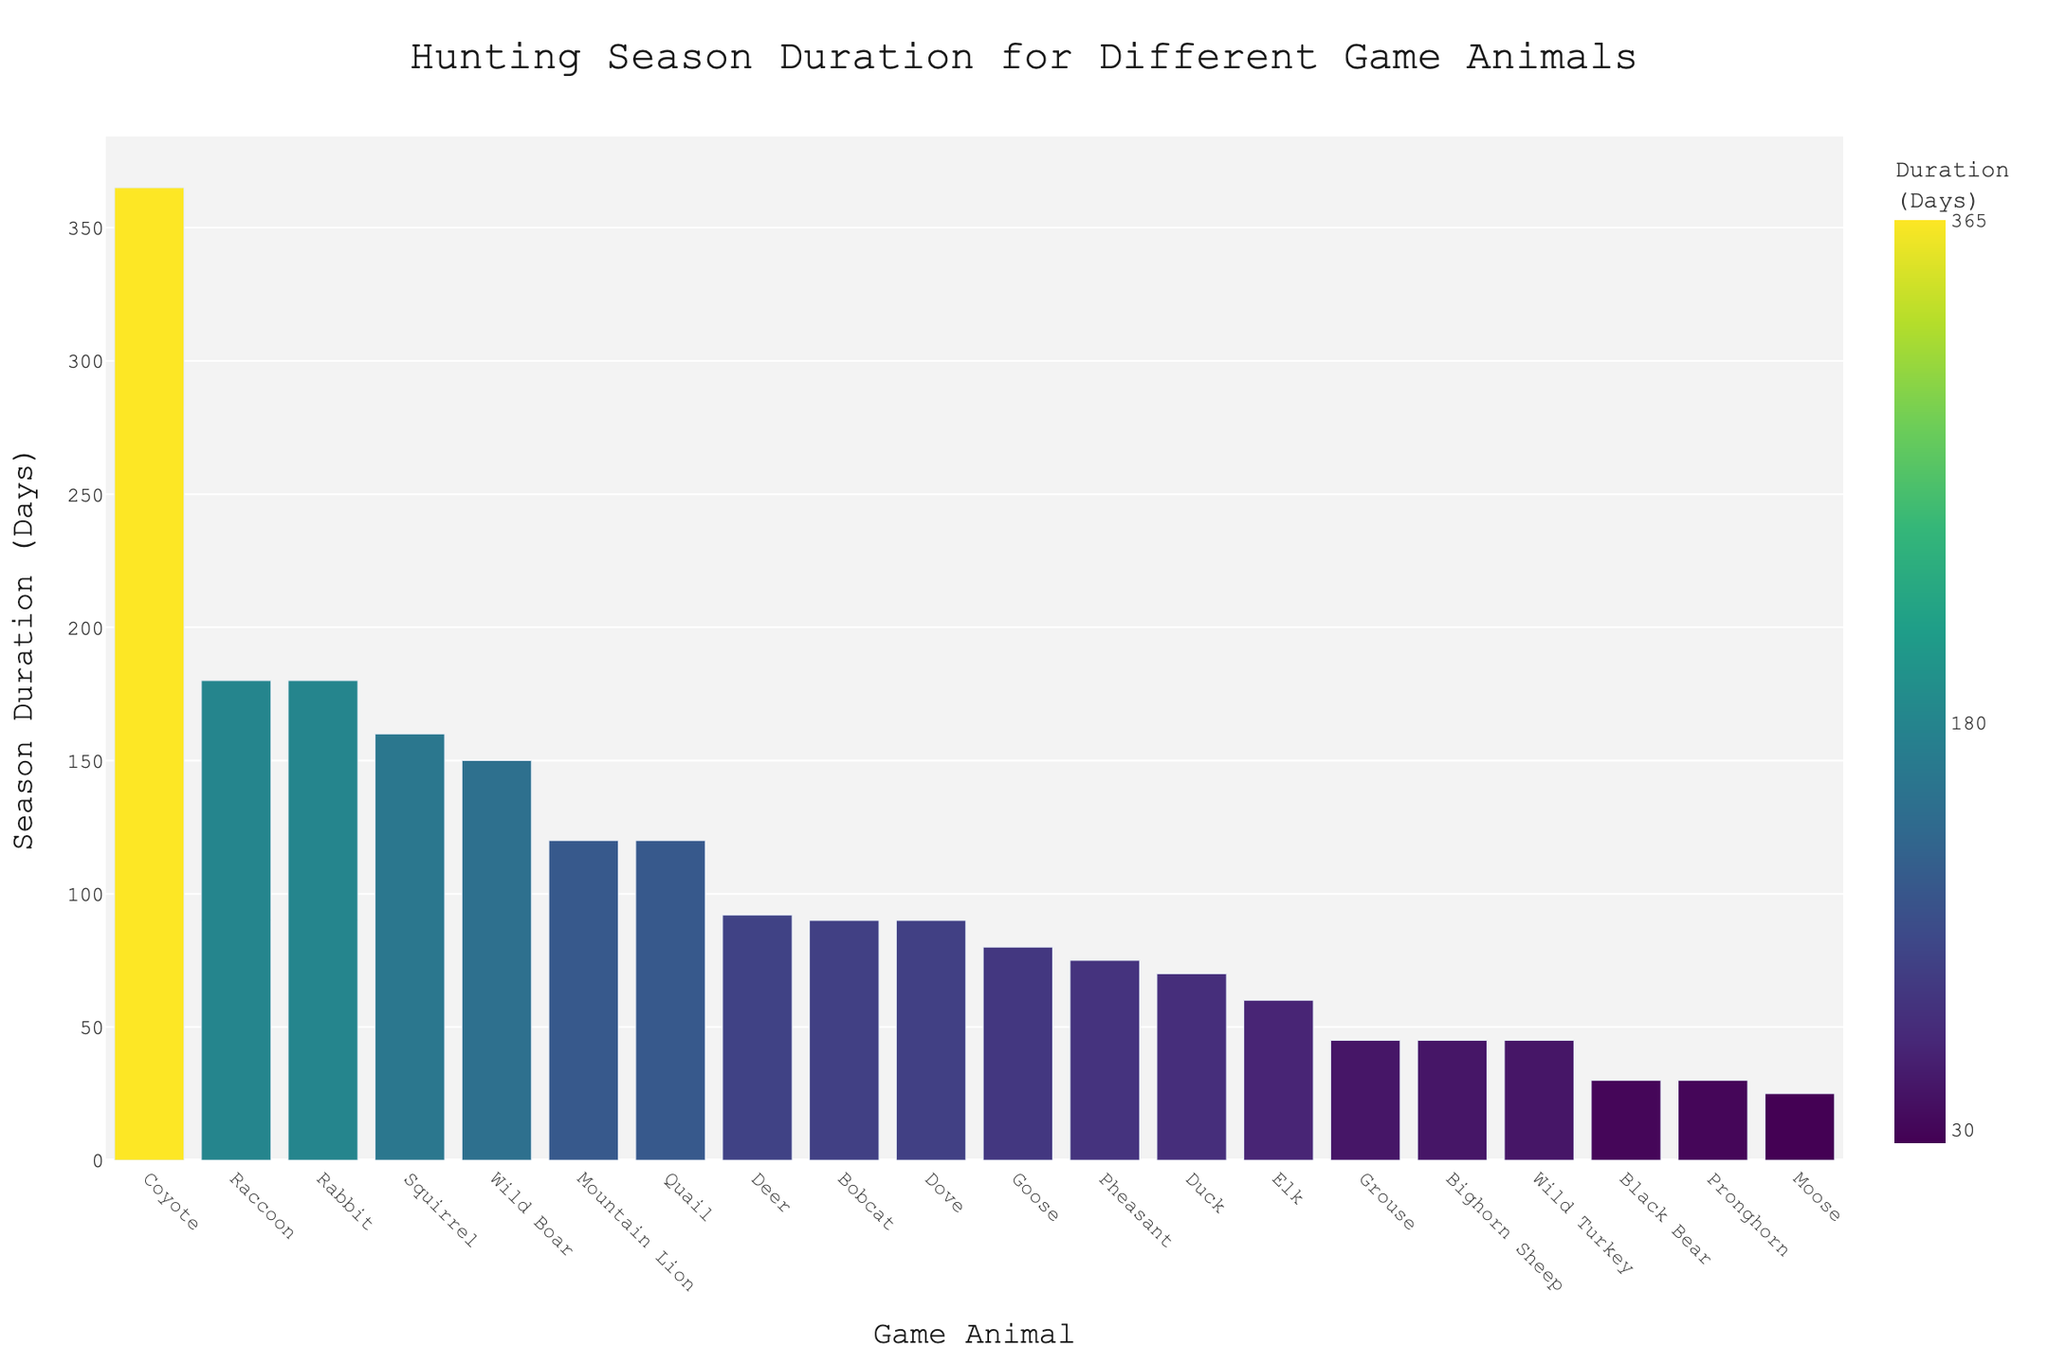Which animal has the longest hunting season? The bar labeled "Coyote" reaches the highest point on the y-axis with 365 days, indicating it has the longest season.
Answer: Coyote Which two animals have the shortest hunting seasons? By looking at the short bars at the bottom of the chart, "Pronghorn" and "Black Bear" both have the shortest season duration with 30 days each.
Answer: Pronghorn and Black Bear What's the total duration of the hunting seasons for Deer and Duck? Deer has 92 days and Duck has 70 days. Summing these gives 92 + 70 = 162 days.
Answer: 162 days What is the average season duration for Wild Turkey, Grouse, and Bighorn Sheep? Adding the durations: 45 (Wild Turkey) + 45 (Grouse) + 45 (Bighorn Sheep) = 135. Dividing by 3 (number of animals): 135 / 3 = 45 days.
Answer: 45 days How much longer is the Goose season compared to the Black Bear season? Goose has 80 days, Black Bear has 30 days. The difference is 80 - 30 = 50 days.
Answer: 50 days Which animals have a season duration longer than 150 days? Identifying the bars exceeding 150 days, we find Rabbit (180), Raccoon (180), and Wild Boar (150, equal to or longer).
Answer: Rabbit and Raccoon Is the season for Mountain Lion longer or shorter than for Bobcat? The bar for Mountain Lion (120 days) is taller than the bar for Bobcat (90 days).
Answer: Longer What is the median duration of all hunting seasons? Listing all durations: 25, 30, 30, 45, 45, 45, 60, 70, 75, 80, 90, 90, 92, 120, 120, 150, 160, 180, 180, 365. The middle two values are 90 and 92, averaging these gives (90+92)/2 = 91 days.
Answer: 91 days Which animal's hunting season is closest in duration to the average duration of all animals? Calculating the average: (25+30+30+45+45+45+60+70+75+80+90+90+92+120+120+150+160+180+180+365) / 20 = 102.85 days. The closest duration is that of Mountain Lion and Quail with 120 days.
Answer: Mountain Lion and Quail 